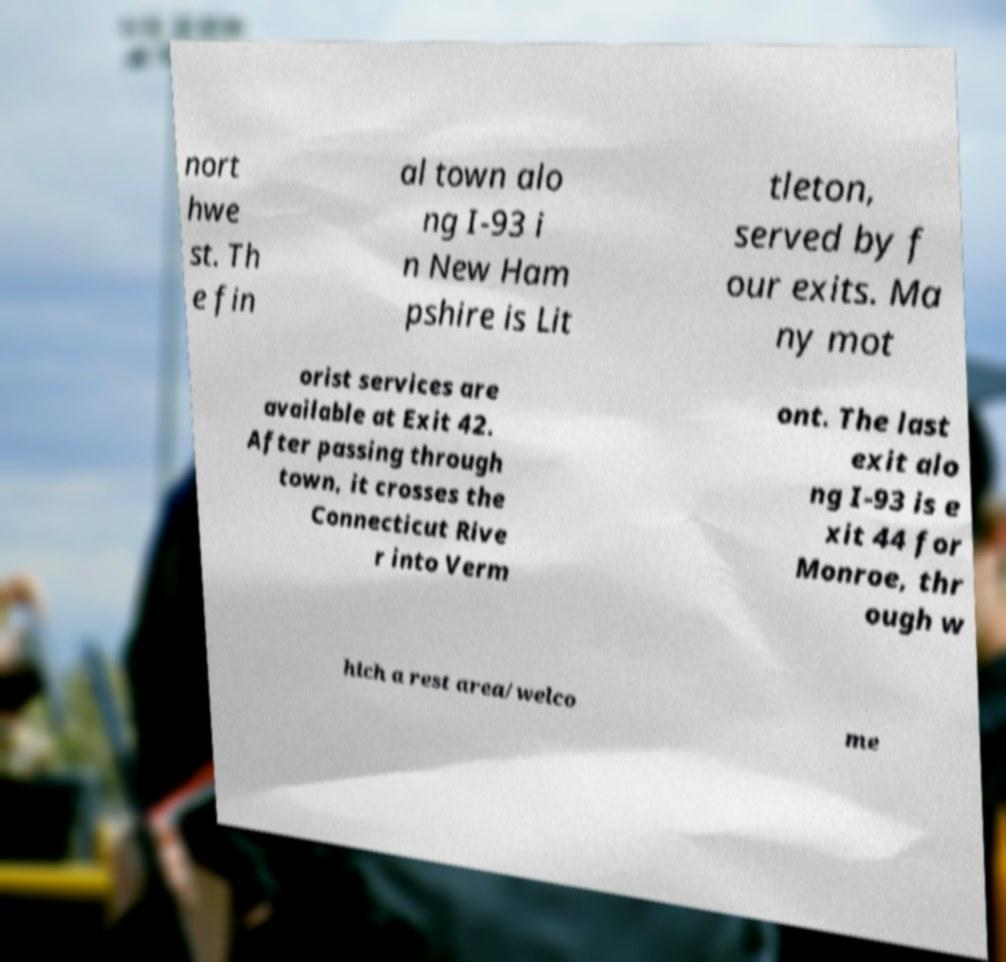Please read and relay the text visible in this image. What does it say? nort hwe st. Th e fin al town alo ng I-93 i n New Ham pshire is Lit tleton, served by f our exits. Ma ny mot orist services are available at Exit 42. After passing through town, it crosses the Connecticut Rive r into Verm ont. The last exit alo ng I-93 is e xit 44 for Monroe, thr ough w hich a rest area/welco me 